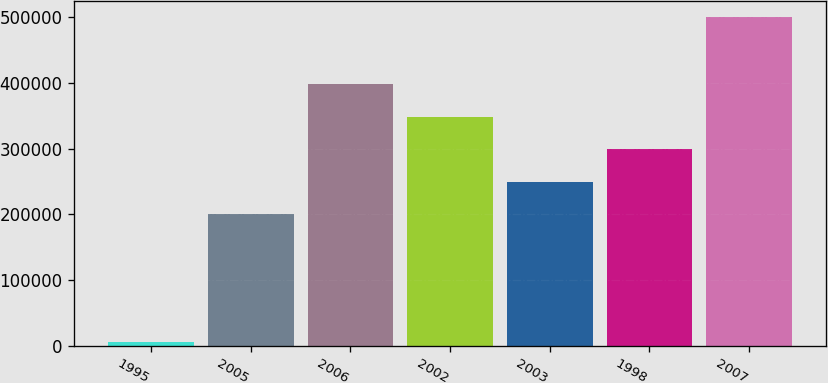Convert chart to OTSL. <chart><loc_0><loc_0><loc_500><loc_500><bar_chart><fcel>1995<fcel>2005<fcel>2006<fcel>2002<fcel>2003<fcel>1998<fcel>2007<nl><fcel>6421<fcel>200000<fcel>397432<fcel>348074<fcel>249358<fcel>298716<fcel>500000<nl></chart> 